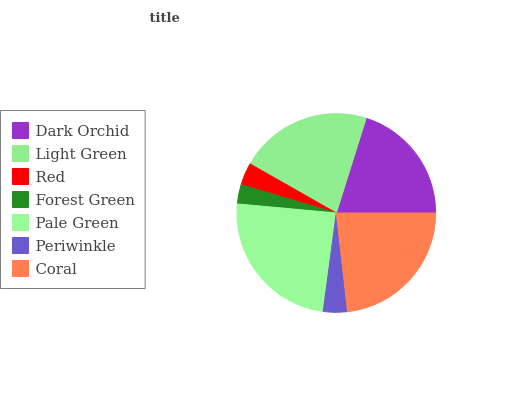Is Forest Green the minimum?
Answer yes or no. Yes. Is Pale Green the maximum?
Answer yes or no. Yes. Is Light Green the minimum?
Answer yes or no. No. Is Light Green the maximum?
Answer yes or no. No. Is Light Green greater than Dark Orchid?
Answer yes or no. Yes. Is Dark Orchid less than Light Green?
Answer yes or no. Yes. Is Dark Orchid greater than Light Green?
Answer yes or no. No. Is Light Green less than Dark Orchid?
Answer yes or no. No. Is Dark Orchid the high median?
Answer yes or no. Yes. Is Dark Orchid the low median?
Answer yes or no. Yes. Is Pale Green the high median?
Answer yes or no. No. Is Coral the low median?
Answer yes or no. No. 